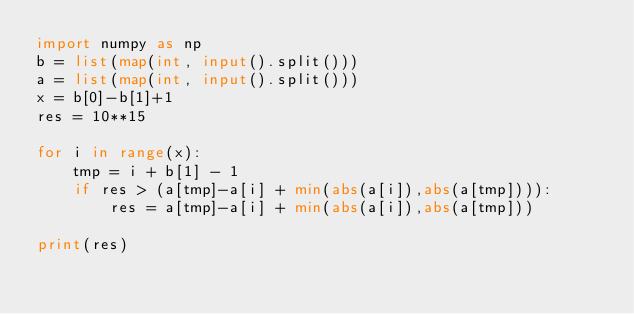Convert code to text. <code><loc_0><loc_0><loc_500><loc_500><_Python_>import numpy as np
b = list(map(int, input().split()))
a = list(map(int, input().split()))
x = b[0]-b[1]+1
res = 10**15
 
for i in range(x):
    tmp = i + b[1] - 1
    if res > (a[tmp]-a[i] + min(abs(a[i]),abs(a[tmp]))):
	    res = a[tmp]-a[i] + min(abs(a[i]),abs(a[tmp]))
        
print(res)</code> 